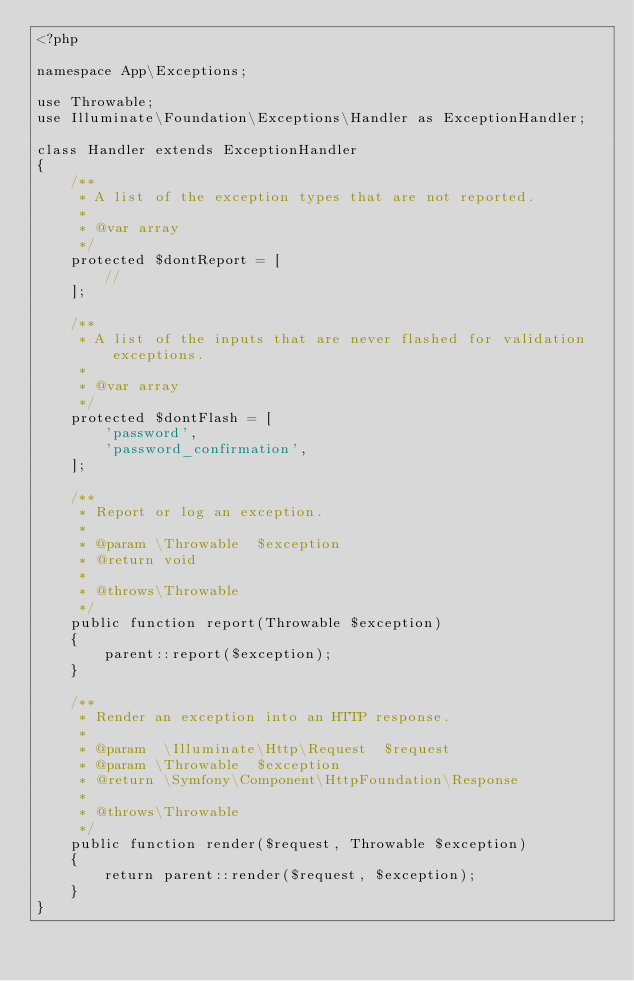<code> <loc_0><loc_0><loc_500><loc_500><_PHP_><?php

namespace App\Exceptions;

use Throwable;
use Illuminate\Foundation\Exceptions\Handler as ExceptionHandler;

class Handler extends ExceptionHandler
{
    /**
     * A list of the exception types that are not reported.
     *
     * @var array
     */
    protected $dontReport = [
        //
    ];

    /**
     * A list of the inputs that are never flashed for validation exceptions.
     *
     * @var array
     */
    protected $dontFlash = [
        'password',
        'password_confirmation',
    ];

    /**
     * Report or log an exception.
     *
     * @param \Throwable  $exception
     * @return void
     *
     * @throws\Throwable
     */
    public function report(Throwable $exception)
    {
        parent::report($exception);
    }

    /**
     * Render an exception into an HTTP response.
     *
     * @param  \Illuminate\Http\Request  $request
     * @param \Throwable  $exception
     * @return \Symfony\Component\HttpFoundation\Response
     *
     * @throws\Throwable
     */
    public function render($request, Throwable $exception)
    {
        return parent::render($request, $exception);
    }
}
</code> 